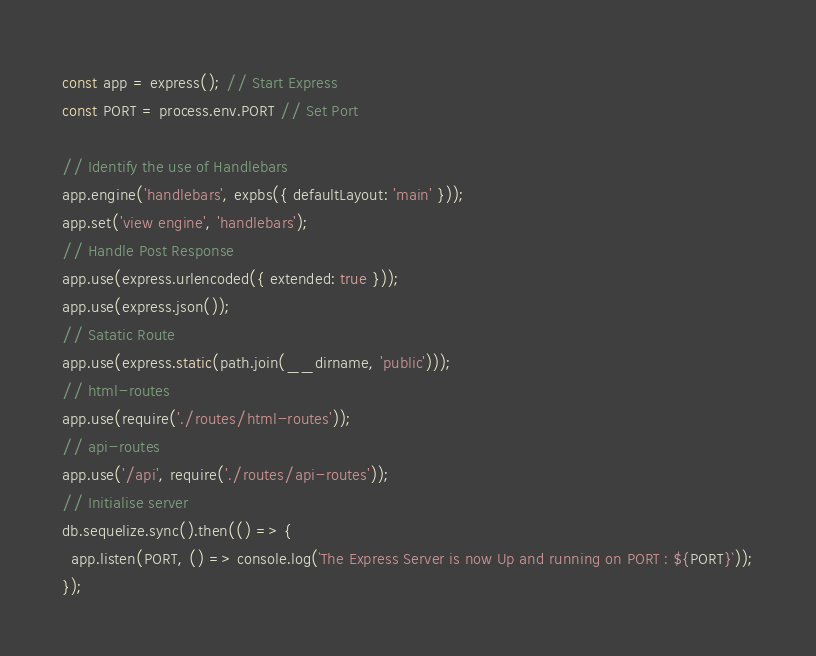Convert code to text. <code><loc_0><loc_0><loc_500><loc_500><_JavaScript_>
const app = express(); // Start Express
const PORT = process.env.PORT // Set Port

// Identify the use of Handlebars
app.engine('handlebars', expbs({ defaultLayout: 'main' }));
app.set('view engine', 'handlebars');
// Handle Post Response
app.use(express.urlencoded({ extended: true }));
app.use(express.json());
// Satatic Route
app.use(express.static(path.join(__dirname, 'public')));
// html-routes
app.use(require('./routes/html-routes'));
// api-routes
app.use('/api', require('./routes/api-routes'));
// Initialise server
db.sequelize.sync().then(() => {
  app.listen(PORT, () => console.log(`The Express Server is now Up and running on PORT : ${PORT}`));
});
</code> 